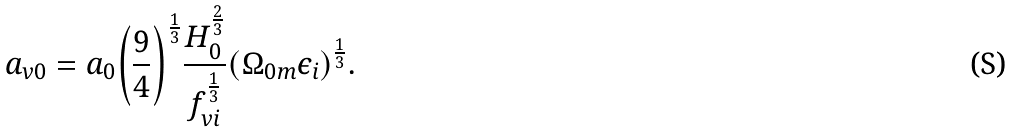<formula> <loc_0><loc_0><loc_500><loc_500>a _ { v 0 } = a _ { 0 } { \left ( \frac { 9 } { 4 } \right ) } ^ { \frac { 1 } { 3 } } \frac { H _ { 0 } ^ { \frac { 2 } { 3 } } } { f _ { v i } ^ { \frac { 1 } { 3 } } } { \left ( { \Omega } _ { 0 m } { \epsilon } _ { i } \right ) } ^ { \frac { 1 } { 3 } } .</formula> 